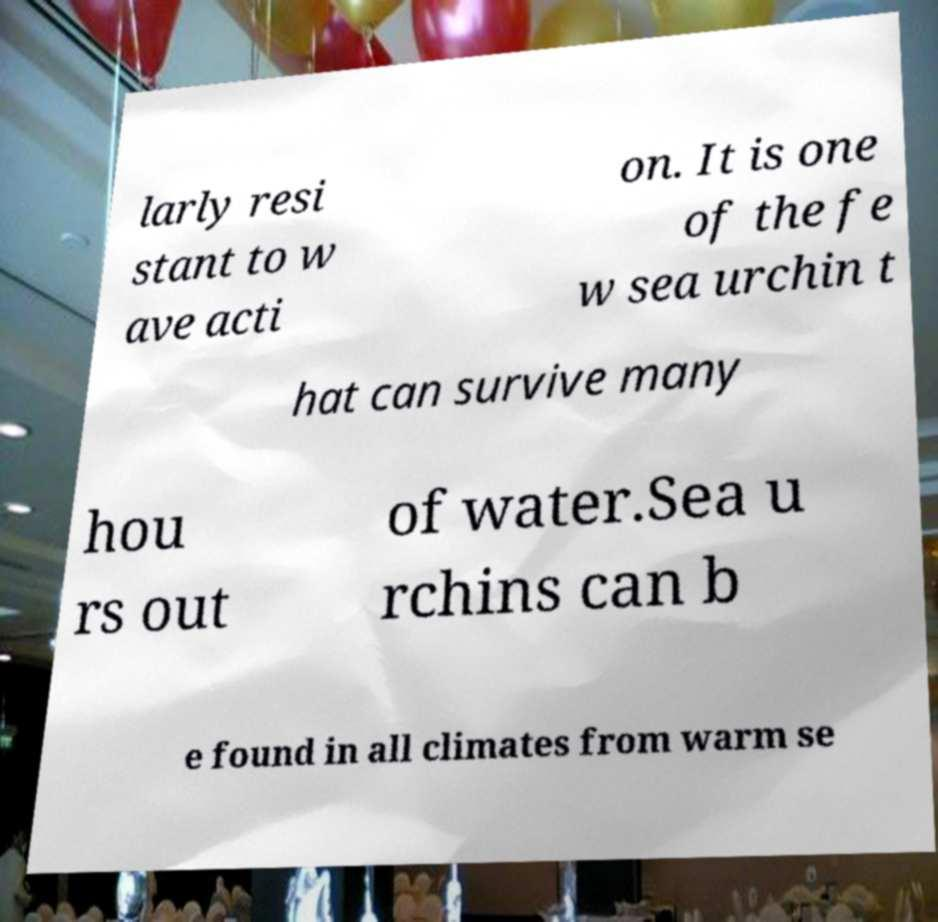What messages or text are displayed in this image? I need them in a readable, typed format. larly resi stant to w ave acti on. It is one of the fe w sea urchin t hat can survive many hou rs out of water.Sea u rchins can b e found in all climates from warm se 